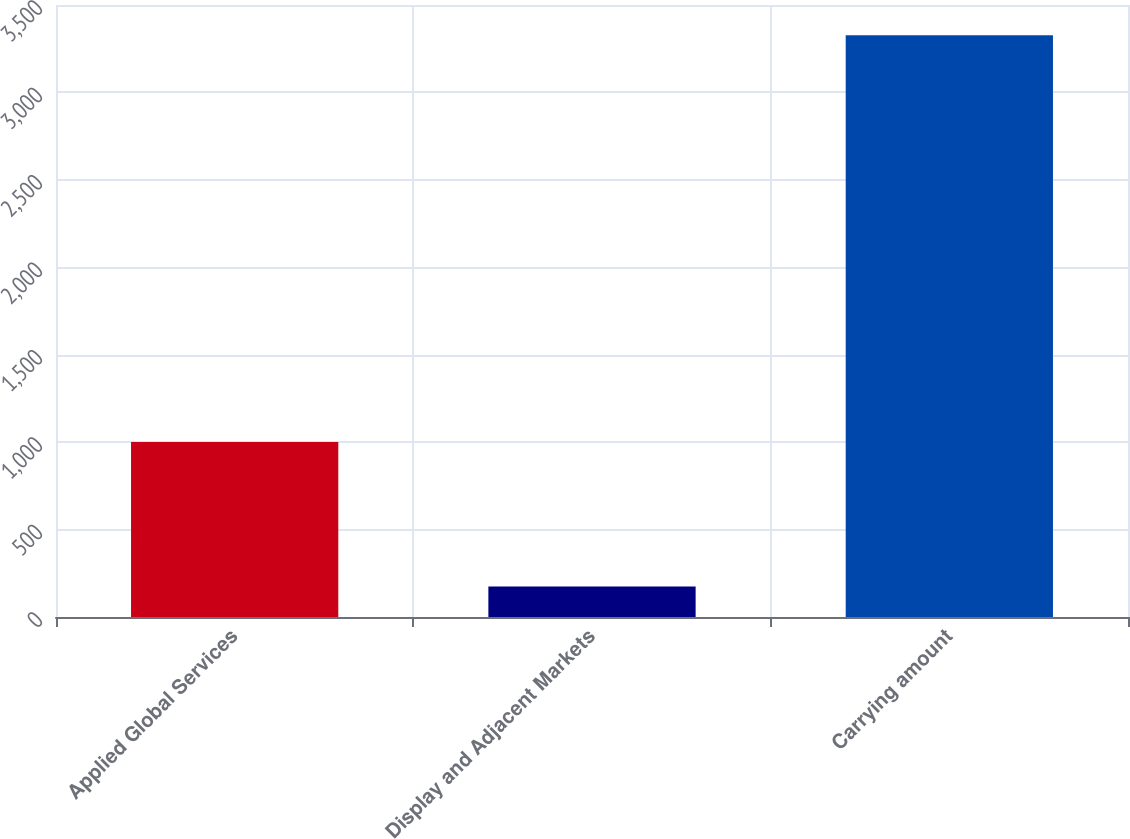Convert chart. <chart><loc_0><loc_0><loc_500><loc_500><bar_chart><fcel>Applied Global Services<fcel>Display and Adjacent Markets<fcel>Carrying amount<nl><fcel>1001<fcel>175<fcel>3327<nl></chart> 